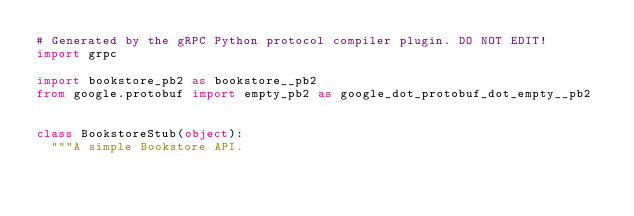<code> <loc_0><loc_0><loc_500><loc_500><_Python_># Generated by the gRPC Python protocol compiler plugin. DO NOT EDIT!
import grpc

import bookstore_pb2 as bookstore__pb2
from google.protobuf import empty_pb2 as google_dot_protobuf_dot_empty__pb2


class BookstoreStub(object):
  """A simple Bookstore API.
</code> 